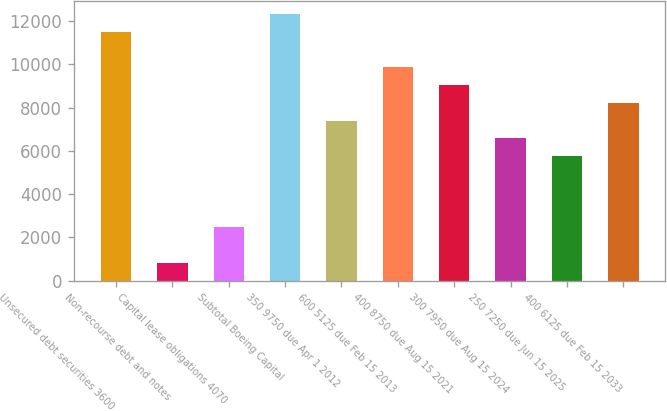Convert chart. <chart><loc_0><loc_0><loc_500><loc_500><bar_chart><fcel>Unsecured debt securities 3600<fcel>Non-recourse debt and notes<fcel>Capital lease obligations 4070<fcel>Subtotal Boeing Capital<fcel>350 9750 due Apr 1 2012<fcel>600 5125 due Feb 15 2013<fcel>400 8750 due Aug 15 2021<fcel>300 7950 due Aug 15 2024<fcel>250 7250 due Jun 15 2025<fcel>400 6125 due Feb 15 2033<nl><fcel>11503<fcel>823.5<fcel>2466.5<fcel>12324.5<fcel>7395.5<fcel>9860<fcel>9038.5<fcel>6574<fcel>5752.5<fcel>8217<nl></chart> 